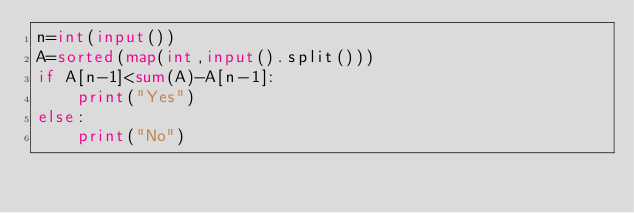Convert code to text. <code><loc_0><loc_0><loc_500><loc_500><_Python_>n=int(input())
A=sorted(map(int,input().split()))
if A[n-1]<sum(A)-A[n-1]:
    print("Yes")
else:
    print("No")</code> 